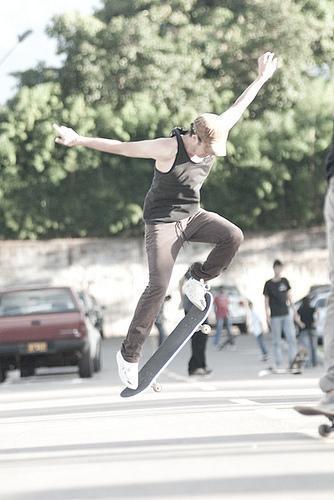How many skateboards are visible?
Give a very brief answer. 4. 